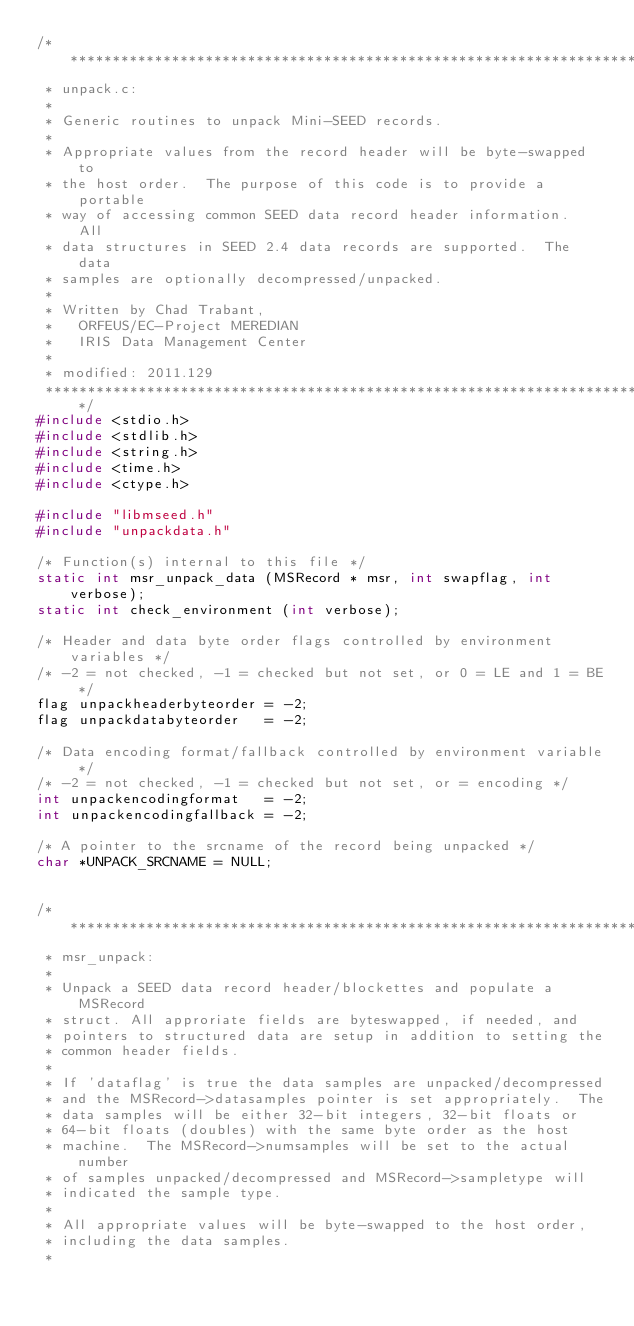Convert code to text. <code><loc_0><loc_0><loc_500><loc_500><_C_>/***************************************************************************
 * unpack.c:
 *
 * Generic routines to unpack Mini-SEED records.
 *
 * Appropriate values from the record header will be byte-swapped to
 * the host order.  The purpose of this code is to provide a portable
 * way of accessing common SEED data record header information.  All
 * data structures in SEED 2.4 data records are supported.  The data
 * samples are optionally decompressed/unpacked.
 *
 * Written by Chad Trabant,
 *   ORFEUS/EC-Project MEREDIAN
 *   IRIS Data Management Center
 *
 * modified: 2011.129
 ***************************************************************************/
#include <stdio.h>
#include <stdlib.h>
#include <string.h>
#include <time.h>
#include <ctype.h>

#include "libmseed.h"
#include "unpackdata.h"

/* Function(s) internal to this file */
static int msr_unpack_data (MSRecord * msr, int swapflag, int verbose);
static int check_environment (int verbose);

/* Header and data byte order flags controlled by environment variables */
/* -2 = not checked, -1 = checked but not set, or 0 = LE and 1 = BE */
flag unpackheaderbyteorder = -2;
flag unpackdatabyteorder   = -2;

/* Data encoding format/fallback controlled by environment variable */
/* -2 = not checked, -1 = checked but not set, or = encoding */
int unpackencodingformat   = -2;
int unpackencodingfallback = -2;

/* A pointer to the srcname of the record being unpacked */
char *UNPACK_SRCNAME = NULL;


/***************************************************************************
 * msr_unpack:
 *
 * Unpack a SEED data record header/blockettes and populate a MSRecord
 * struct. All approriate fields are byteswapped, if needed, and
 * pointers to structured data are setup in addition to setting the
 * common header fields.
 *
 * If 'dataflag' is true the data samples are unpacked/decompressed
 * and the MSRecord->datasamples pointer is set appropriately.  The
 * data samples will be either 32-bit integers, 32-bit floats or
 * 64-bit floats (doubles) with the same byte order as the host
 * machine.  The MSRecord->numsamples will be set to the actual number
 * of samples unpacked/decompressed and MSRecord->sampletype will
 * indicated the sample type.
 *
 * All appropriate values will be byte-swapped to the host order,
 * including the data samples.
 *</code> 